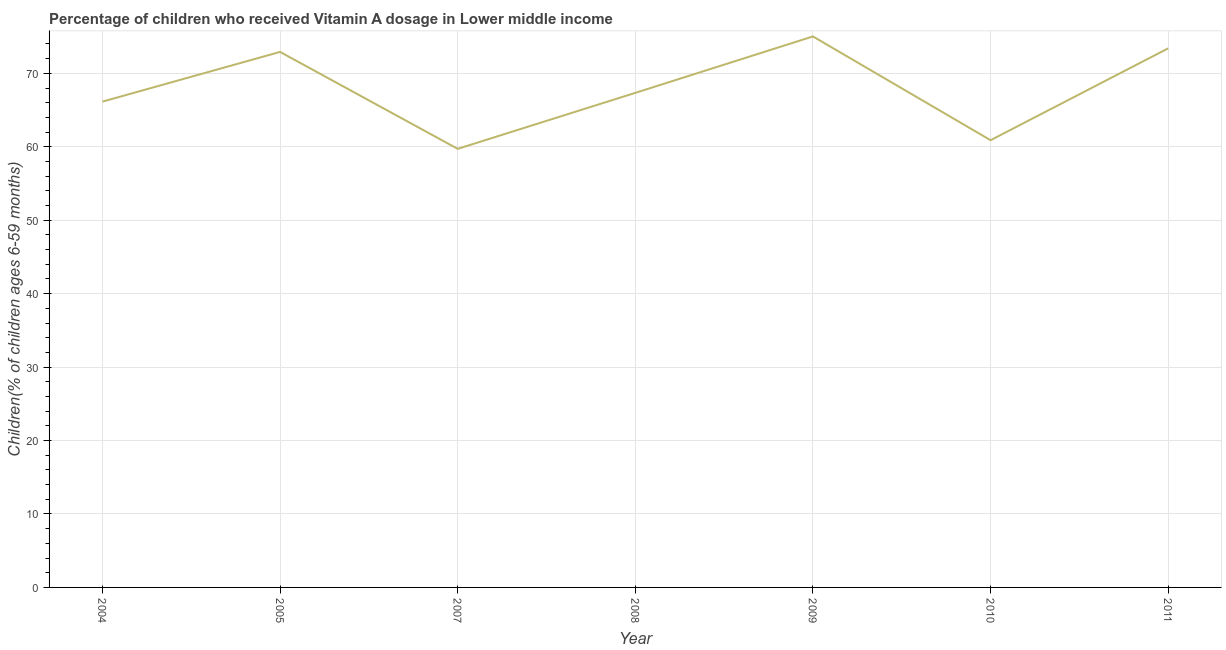What is the vitamin a supplementation coverage rate in 2008?
Make the answer very short. 67.34. Across all years, what is the maximum vitamin a supplementation coverage rate?
Offer a very short reply. 75.02. Across all years, what is the minimum vitamin a supplementation coverage rate?
Offer a very short reply. 59.72. In which year was the vitamin a supplementation coverage rate maximum?
Your response must be concise. 2009. What is the sum of the vitamin a supplementation coverage rate?
Your answer should be very brief. 475.45. What is the difference between the vitamin a supplementation coverage rate in 2010 and 2011?
Your answer should be very brief. -12.51. What is the average vitamin a supplementation coverage rate per year?
Ensure brevity in your answer.  67.92. What is the median vitamin a supplementation coverage rate?
Provide a succinct answer. 67.34. In how many years, is the vitamin a supplementation coverage rate greater than 40 %?
Your answer should be compact. 7. What is the ratio of the vitamin a supplementation coverage rate in 2007 to that in 2010?
Provide a short and direct response. 0.98. Is the vitamin a supplementation coverage rate in 2008 less than that in 2009?
Make the answer very short. Yes. What is the difference between the highest and the second highest vitamin a supplementation coverage rate?
Your response must be concise. 1.62. What is the difference between the highest and the lowest vitamin a supplementation coverage rate?
Provide a short and direct response. 15.3. In how many years, is the vitamin a supplementation coverage rate greater than the average vitamin a supplementation coverage rate taken over all years?
Your answer should be very brief. 3. Does the vitamin a supplementation coverage rate monotonically increase over the years?
Offer a terse response. No. How many lines are there?
Your response must be concise. 1. What is the difference between two consecutive major ticks on the Y-axis?
Give a very brief answer. 10. Does the graph contain any zero values?
Provide a short and direct response. No. Does the graph contain grids?
Offer a very short reply. Yes. What is the title of the graph?
Provide a succinct answer. Percentage of children who received Vitamin A dosage in Lower middle income. What is the label or title of the X-axis?
Your response must be concise. Year. What is the label or title of the Y-axis?
Your answer should be very brief. Children(% of children ages 6-59 months). What is the Children(% of children ages 6-59 months) in 2004?
Make the answer very short. 66.15. What is the Children(% of children ages 6-59 months) of 2005?
Your response must be concise. 72.92. What is the Children(% of children ages 6-59 months) of 2007?
Your response must be concise. 59.72. What is the Children(% of children ages 6-59 months) of 2008?
Offer a terse response. 67.34. What is the Children(% of children ages 6-59 months) in 2009?
Ensure brevity in your answer.  75.02. What is the Children(% of children ages 6-59 months) in 2010?
Give a very brief answer. 60.9. What is the Children(% of children ages 6-59 months) in 2011?
Make the answer very short. 73.4. What is the difference between the Children(% of children ages 6-59 months) in 2004 and 2005?
Your answer should be very brief. -6.77. What is the difference between the Children(% of children ages 6-59 months) in 2004 and 2007?
Your response must be concise. 6.43. What is the difference between the Children(% of children ages 6-59 months) in 2004 and 2008?
Your answer should be compact. -1.2. What is the difference between the Children(% of children ages 6-59 months) in 2004 and 2009?
Keep it short and to the point. -8.88. What is the difference between the Children(% of children ages 6-59 months) in 2004 and 2010?
Your answer should be compact. 5.25. What is the difference between the Children(% of children ages 6-59 months) in 2004 and 2011?
Offer a terse response. -7.26. What is the difference between the Children(% of children ages 6-59 months) in 2005 and 2007?
Give a very brief answer. 13.2. What is the difference between the Children(% of children ages 6-59 months) in 2005 and 2008?
Give a very brief answer. 5.57. What is the difference between the Children(% of children ages 6-59 months) in 2005 and 2009?
Provide a succinct answer. -2.11. What is the difference between the Children(% of children ages 6-59 months) in 2005 and 2010?
Your answer should be compact. 12.02. What is the difference between the Children(% of children ages 6-59 months) in 2005 and 2011?
Your response must be concise. -0.49. What is the difference between the Children(% of children ages 6-59 months) in 2007 and 2008?
Your response must be concise. -7.62. What is the difference between the Children(% of children ages 6-59 months) in 2007 and 2009?
Ensure brevity in your answer.  -15.3. What is the difference between the Children(% of children ages 6-59 months) in 2007 and 2010?
Provide a succinct answer. -1.18. What is the difference between the Children(% of children ages 6-59 months) in 2007 and 2011?
Your answer should be compact. -13.68. What is the difference between the Children(% of children ages 6-59 months) in 2008 and 2009?
Keep it short and to the point. -7.68. What is the difference between the Children(% of children ages 6-59 months) in 2008 and 2010?
Your answer should be compact. 6.45. What is the difference between the Children(% of children ages 6-59 months) in 2008 and 2011?
Give a very brief answer. -6.06. What is the difference between the Children(% of children ages 6-59 months) in 2009 and 2010?
Your answer should be very brief. 14.13. What is the difference between the Children(% of children ages 6-59 months) in 2009 and 2011?
Provide a short and direct response. 1.62. What is the difference between the Children(% of children ages 6-59 months) in 2010 and 2011?
Keep it short and to the point. -12.51. What is the ratio of the Children(% of children ages 6-59 months) in 2004 to that in 2005?
Make the answer very short. 0.91. What is the ratio of the Children(% of children ages 6-59 months) in 2004 to that in 2007?
Provide a short and direct response. 1.11. What is the ratio of the Children(% of children ages 6-59 months) in 2004 to that in 2008?
Offer a very short reply. 0.98. What is the ratio of the Children(% of children ages 6-59 months) in 2004 to that in 2009?
Ensure brevity in your answer.  0.88. What is the ratio of the Children(% of children ages 6-59 months) in 2004 to that in 2010?
Provide a short and direct response. 1.09. What is the ratio of the Children(% of children ages 6-59 months) in 2004 to that in 2011?
Provide a succinct answer. 0.9. What is the ratio of the Children(% of children ages 6-59 months) in 2005 to that in 2007?
Provide a succinct answer. 1.22. What is the ratio of the Children(% of children ages 6-59 months) in 2005 to that in 2008?
Your answer should be compact. 1.08. What is the ratio of the Children(% of children ages 6-59 months) in 2005 to that in 2010?
Keep it short and to the point. 1.2. What is the ratio of the Children(% of children ages 6-59 months) in 2005 to that in 2011?
Provide a succinct answer. 0.99. What is the ratio of the Children(% of children ages 6-59 months) in 2007 to that in 2008?
Provide a short and direct response. 0.89. What is the ratio of the Children(% of children ages 6-59 months) in 2007 to that in 2009?
Your answer should be very brief. 0.8. What is the ratio of the Children(% of children ages 6-59 months) in 2007 to that in 2011?
Your answer should be compact. 0.81. What is the ratio of the Children(% of children ages 6-59 months) in 2008 to that in 2009?
Offer a very short reply. 0.9. What is the ratio of the Children(% of children ages 6-59 months) in 2008 to that in 2010?
Give a very brief answer. 1.11. What is the ratio of the Children(% of children ages 6-59 months) in 2008 to that in 2011?
Your response must be concise. 0.92. What is the ratio of the Children(% of children ages 6-59 months) in 2009 to that in 2010?
Provide a short and direct response. 1.23. What is the ratio of the Children(% of children ages 6-59 months) in 2009 to that in 2011?
Your response must be concise. 1.02. What is the ratio of the Children(% of children ages 6-59 months) in 2010 to that in 2011?
Offer a very short reply. 0.83. 